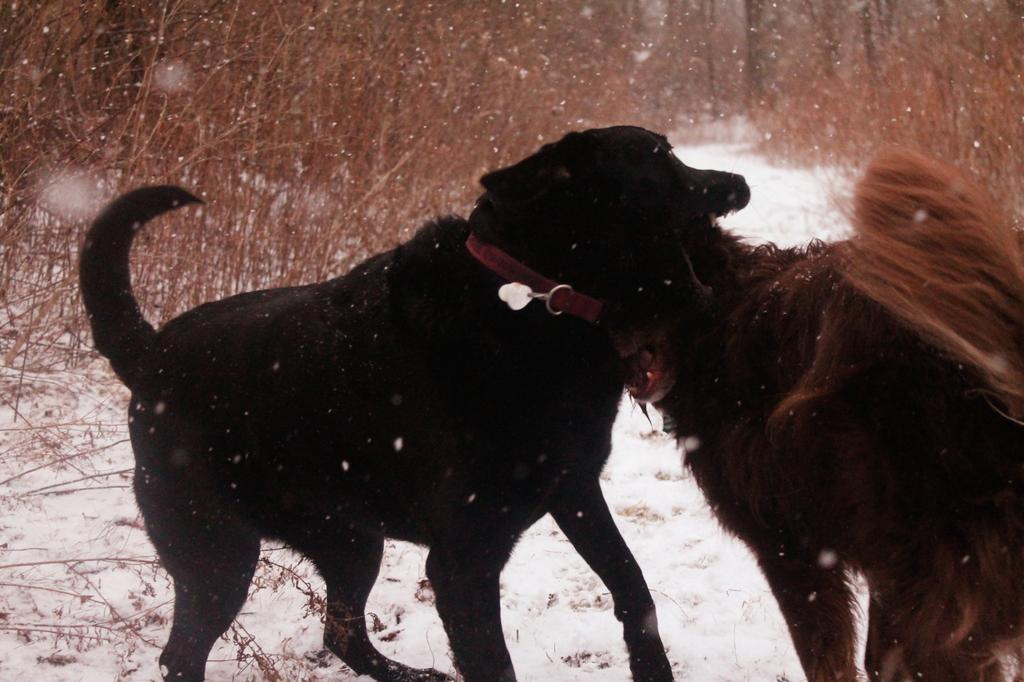What is the main subject of the image? There are animals standing in the image. What can be seen in the background of the image? There are dry plants in the background of the image. What is the condition of the ground in the image? There is snow on the ground in the image. What type of apparel are the snails wearing in the image? There are no snails present in the image, and therefore no apparel can be observed. 